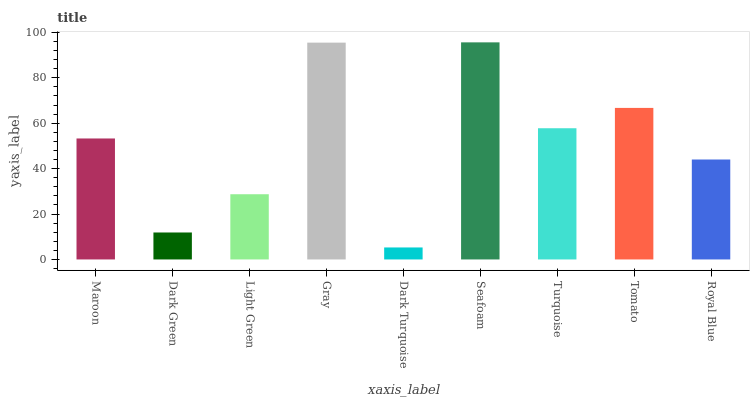Is Dark Green the minimum?
Answer yes or no. No. Is Dark Green the maximum?
Answer yes or no. No. Is Maroon greater than Dark Green?
Answer yes or no. Yes. Is Dark Green less than Maroon?
Answer yes or no. Yes. Is Dark Green greater than Maroon?
Answer yes or no. No. Is Maroon less than Dark Green?
Answer yes or no. No. Is Maroon the high median?
Answer yes or no. Yes. Is Maroon the low median?
Answer yes or no. Yes. Is Seafoam the high median?
Answer yes or no. No. Is Light Green the low median?
Answer yes or no. No. 